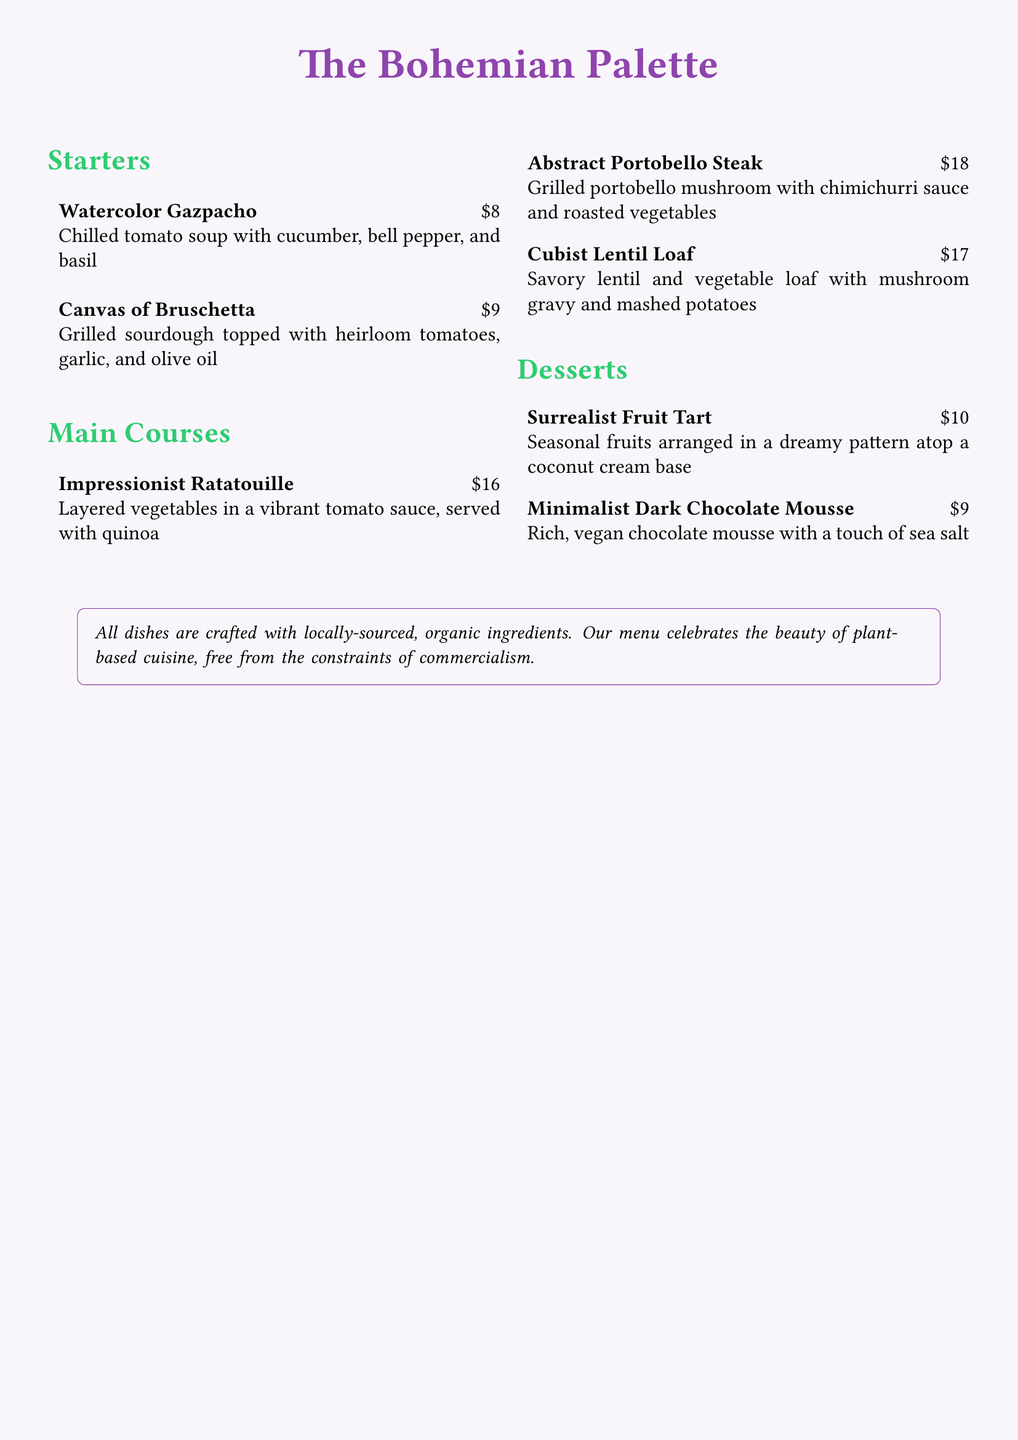what is the name of the restaurant? The restaurant name is presented prominently at the top of the menu.
Answer: The Bohemian Palette how much does the Watercolor Gazpacho cost? This is found in the Starters section of the menu where the prices are listed next to each item.
Answer: $8 what is the main ingredient in the Abstract Portobello Steak? The main ingredient is identified in the dish's description.
Answer: Portobello mushroom how many desserts are listed on the menu? The number of desserts can be counted from the Desserts section.
Answer: 2 which dish is served with quinoa? This information can be gathered from the description of the main courses.
Answer: Impressionist Ratatouille what color is used for the main course section title? The color of the section title is indicated in the formatting of the document.
Answer: Vegetarian what type of mousse is offered on the menu? The specific type of dessert can be found by reading the Desserts section.
Answer: Dark Chocolate Mousse what is the focus of the menu according to the note at the bottom? The note explains the restaurant's philosophy regarding its cuisine.
Answer: Plant-based cuisine which dish has a price of $17? The price is provided in the main courses area and needs to be matched with the dish name.
Answer: Cubist Lentil Loaf 